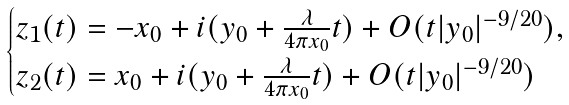Convert formula to latex. <formula><loc_0><loc_0><loc_500><loc_500>\begin{cases} z _ { 1 } ( t ) = - x _ { 0 } + i ( y _ { 0 } + \frac { \lambda } { 4 \pi x _ { 0 } } t ) + O ( t | y _ { 0 } | ^ { - 9 / 2 0 } ) , \\ z _ { 2 } ( t ) = x _ { 0 } + i ( y _ { 0 } + \frac { \lambda } { 4 \pi x _ { 0 } } t ) + O ( t | y _ { 0 } | ^ { - 9 / 2 0 } ) \end{cases}</formula> 